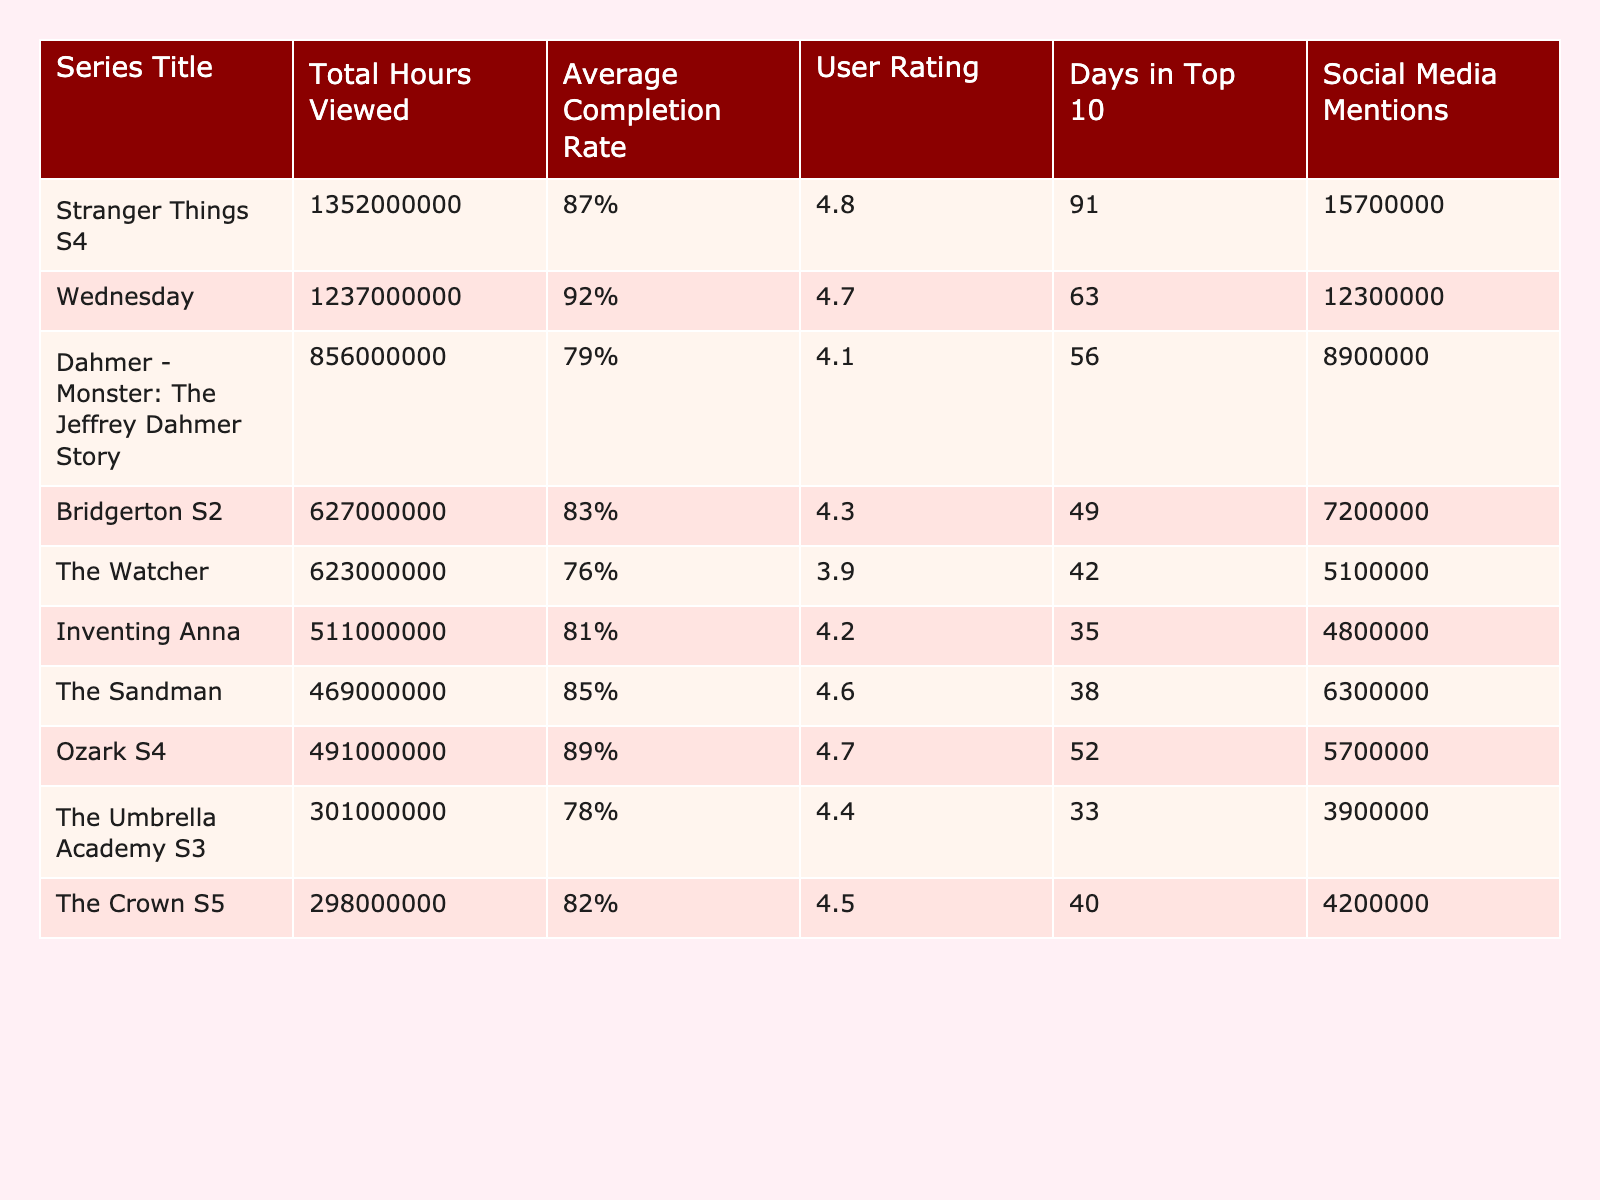What is the total hours viewed for "Stranger Things S4"? From the table, the total hours viewed for "Stranger Things S4" is listed directly under the 'Total Hours Viewed' column. It shows a value of 1,352,000,000 hours.
Answer: 1,352,000,000 Which series has the highest average completion rate? By comparing the 'Average Completion Rate' values for each series, "Wednesday" has the highest completion rate at 92%.
Answer: 92% How many days did "Dahmer - Monster: The Jeffrey Dahmer Story" spend in the top 10? The table specifies that "Dahmer - Monster: The Jeffrey Dahmer Story" spent 56 days in the top 10, as shown in the 'Days in Top 10' column.
Answer: 56 What is the average user rating of all the series listed? To calculate the average user rating, sum the ratings (4.8 + 4.7 + 4.1 + 4.3 + 3.9 + 4.2 + 4.6 + 4.7 + 4.4 + 4.5 = 45.3) and divide by the number of series (10). The average user rating is 45.3 / 10 = 4.53.
Answer: 4.53 Is the total hours viewed for "The Crown S5" more than 300 million? The table shows that "The Crown S5" has 298 million total hours viewed, which is less than 300 million.
Answer: No Which series has the least social media mentions? Comparing the 'Social Media Mentions' values, "The Umbrella Academy S3" has the lowest at 3,900,000 mentions.
Answer: The Umbrella Academy S3 How does the average completion rate of "Ozark S4" compare to "The Watcher"? "Ozark S4" has an average completion rate of 89%, while "The Watcher" has 76%. Therefore, "Ozark S4" has a higher completion rate by 13%.
Answer: Ozark S4 is higher by 13% What is the total social media mentions for the top two series? The social media mentions for "Stranger Things S4" is 15,700,000 and for "Wednesday" is 12,300,000. So, total social media mentions for both series is 15,700,000 + 12,300,000 = 28,000,000.
Answer: 28,000,000 Can we say that the average user rating of "Bridgerton S2" is greater than 4? The user rating for "Bridgerton S2" is 4.3, which is greater than 4. Therefore, we can say yes.
Answer: Yes What is the difference in total hours viewed between "Wednesday" and "Ozark S4"? The total hours viewed for "Wednesday" is 1,237,000,000 and for "Ozark S4", it is 491,000,000. The difference is 1,237,000,000 - 491,000,000 = 746,000,000.
Answer: 746,000,000 